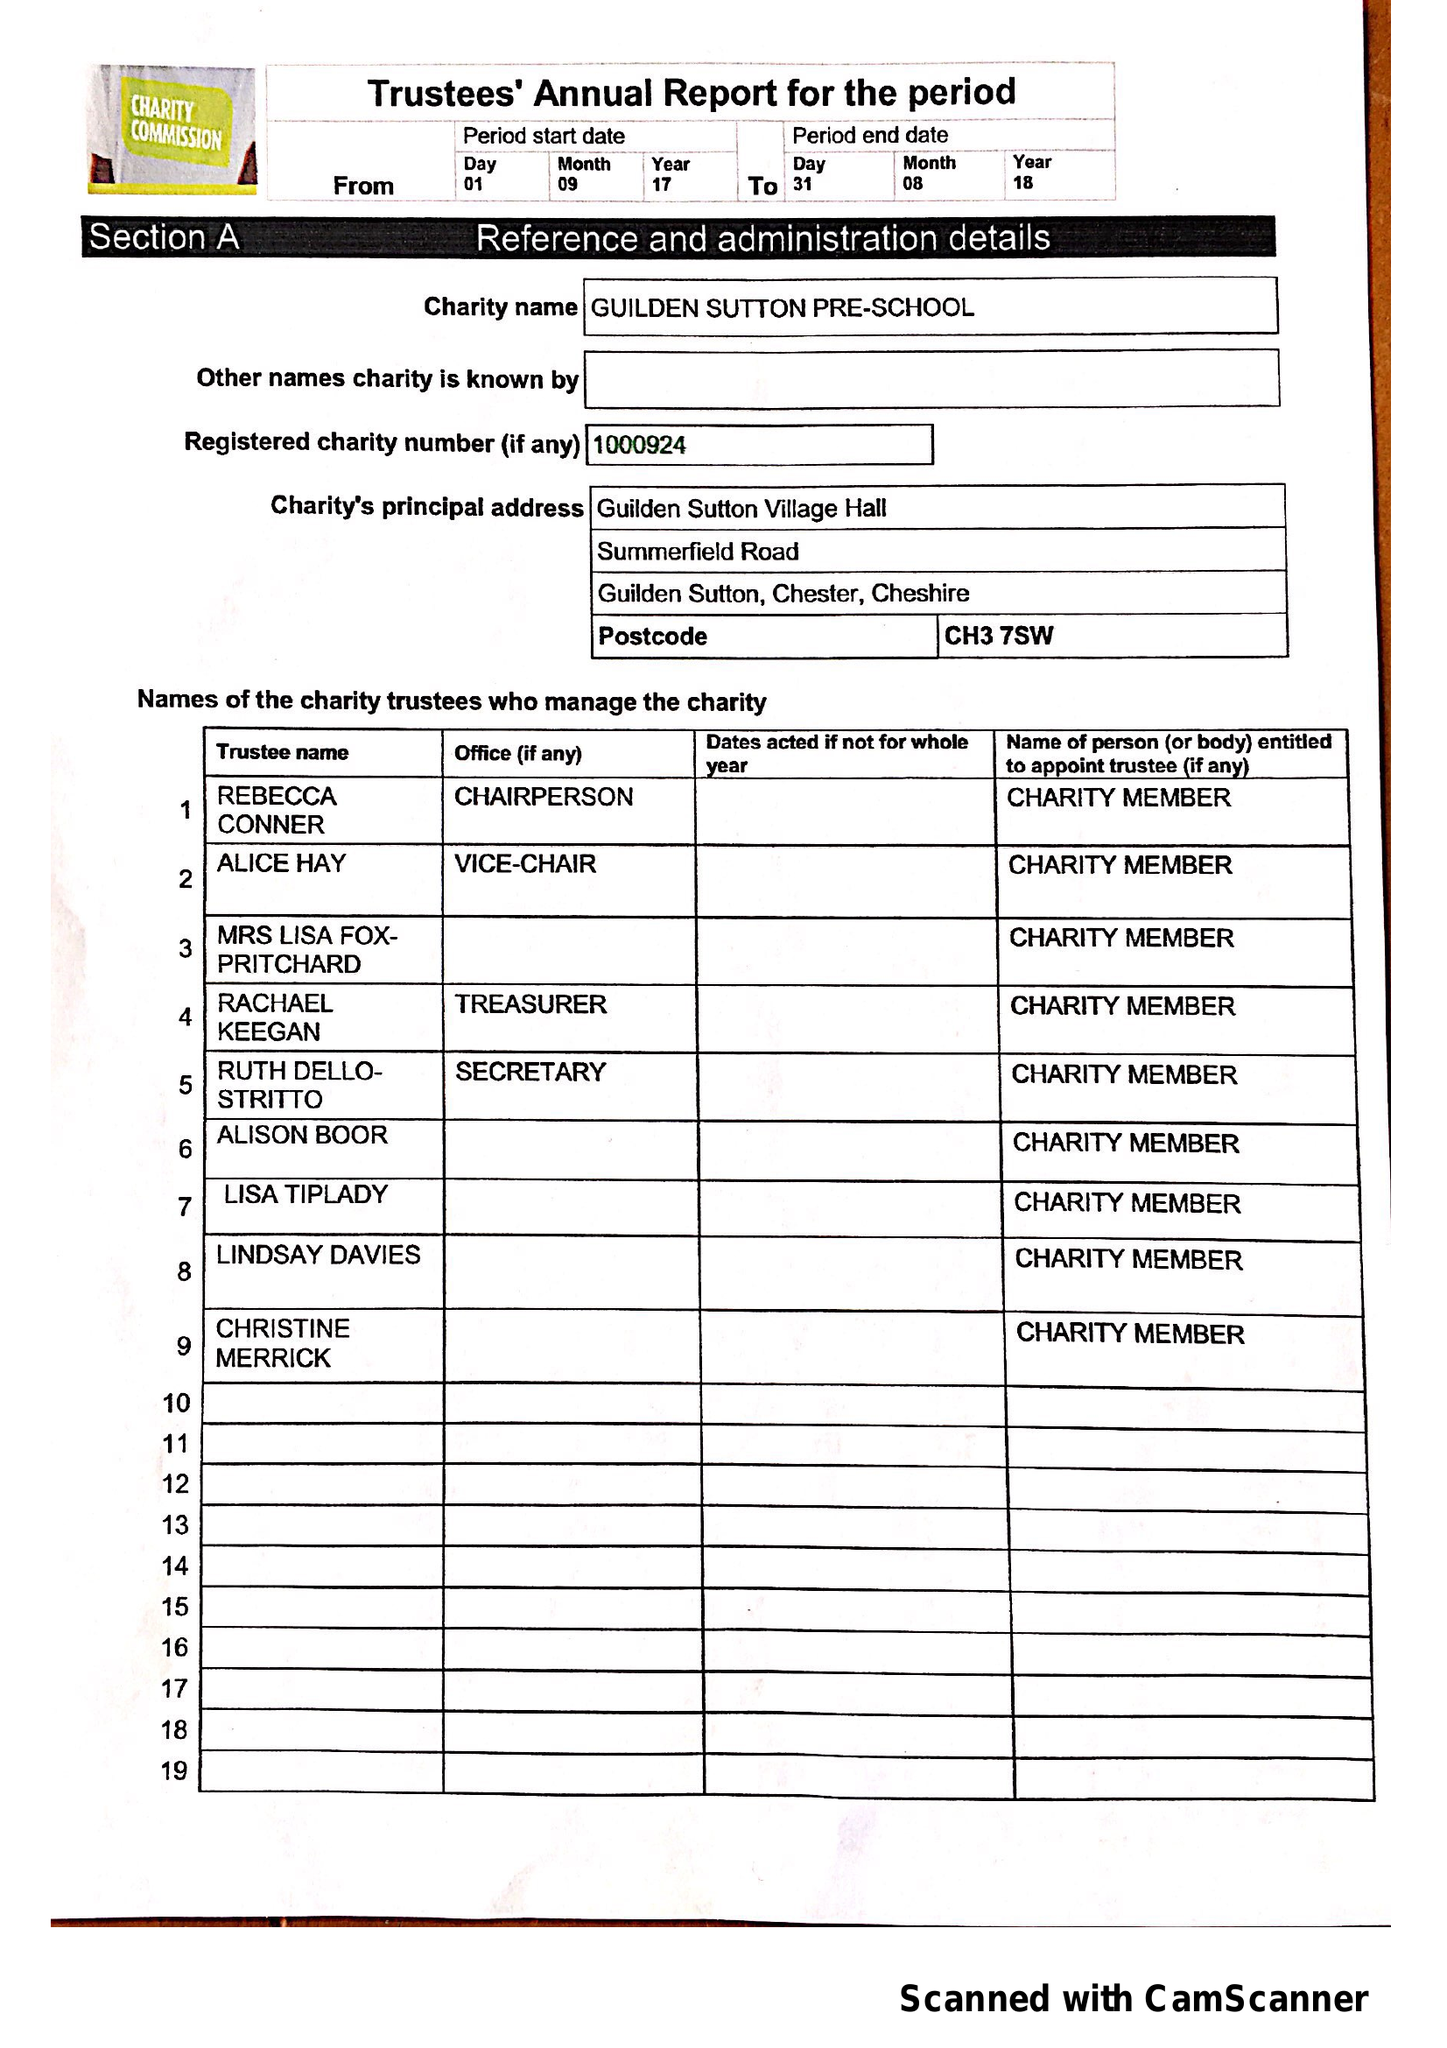What is the value for the report_date?
Answer the question using a single word or phrase. 2018-08-31 